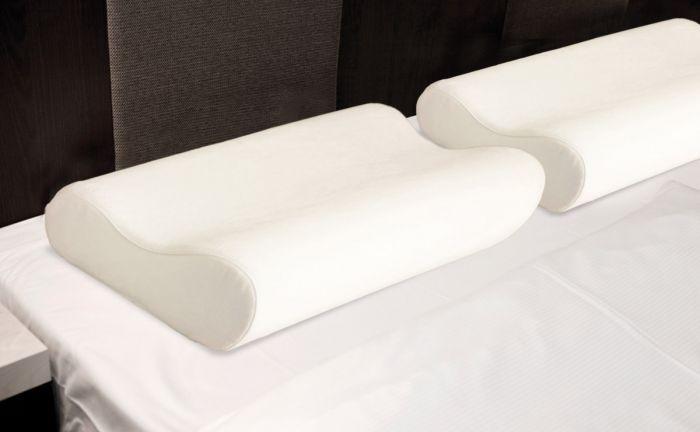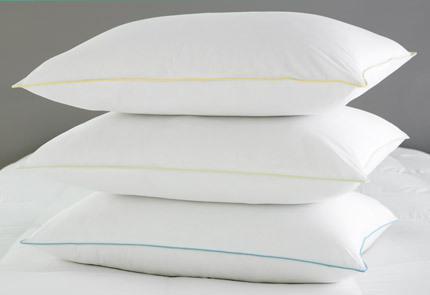The first image is the image on the left, the second image is the image on the right. Considering the images on both sides, is "There are more pillows in the image on the right." valid? Answer yes or no. Yes. The first image is the image on the left, the second image is the image on the right. Given the left and right images, does the statement "One image features a sculpted pillow style with a concave shape, and the other image features a pillow style with pointed corners." hold true? Answer yes or no. Yes. 